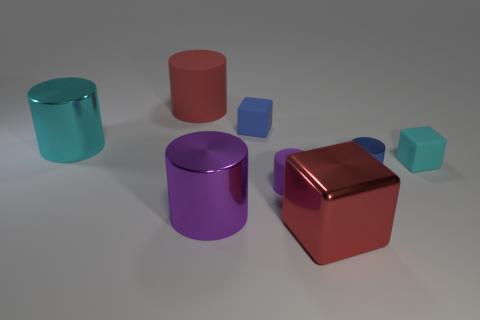What number of cyan objects have the same material as the red cylinder?
Your answer should be compact. 1. What is the color of the block that is made of the same material as the large cyan object?
Provide a short and direct response. Red. Do the cyan metallic object and the matte cylinder behind the large cyan shiny cylinder have the same size?
Offer a terse response. Yes. The cyan metallic thing has what shape?
Your response must be concise. Cylinder. What number of rubber cubes have the same color as the large rubber cylinder?
Ensure brevity in your answer.  0. There is a big matte object that is the same shape as the small blue metallic object; what color is it?
Provide a succinct answer. Red. How many cylinders are to the right of the tiny blue thing left of the red shiny object?
Offer a terse response. 2. What number of balls are purple objects or big purple things?
Offer a very short reply. 0. Is there a brown rubber cube?
Make the answer very short. No. The red matte object that is the same shape as the small purple object is what size?
Provide a succinct answer. Large. 